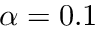Convert formula to latex. <formula><loc_0><loc_0><loc_500><loc_500>\alpha = 0 . 1</formula> 